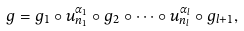Convert formula to latex. <formula><loc_0><loc_0><loc_500><loc_500>g = g _ { 1 } \circ u _ { n _ { 1 } } ^ { \alpha _ { 1 } } \circ g _ { 2 } \circ \cdots \circ u _ { n _ { l } } ^ { \alpha _ { l } } \circ g _ { l + 1 } ,</formula> 